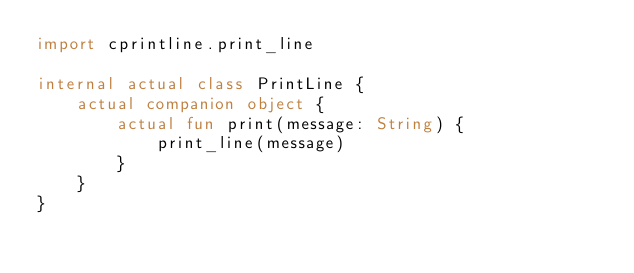<code> <loc_0><loc_0><loc_500><loc_500><_Kotlin_>import cprintline.print_line

internal actual class PrintLine {
    actual companion object {
        actual fun print(message: String) {
            print_line(message)
        }
    }
}</code> 